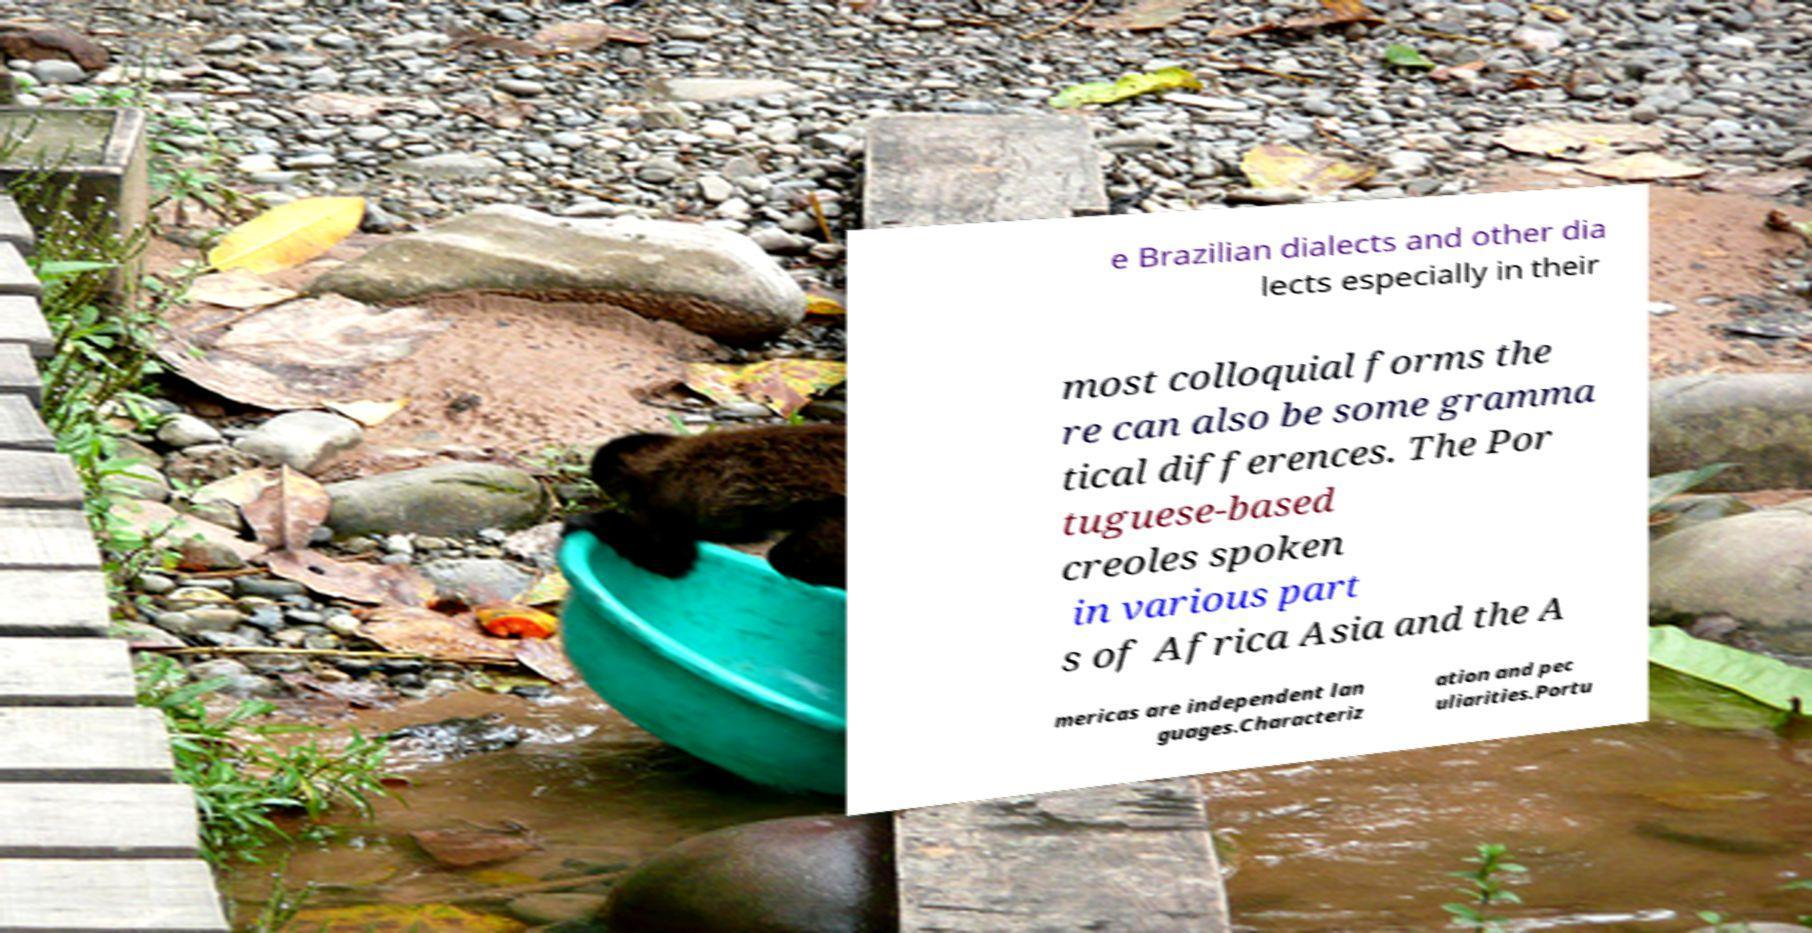Could you assist in decoding the text presented in this image and type it out clearly? e Brazilian dialects and other dia lects especially in their most colloquial forms the re can also be some gramma tical differences. The Por tuguese-based creoles spoken in various part s of Africa Asia and the A mericas are independent lan guages.Characteriz ation and pec uliarities.Portu 